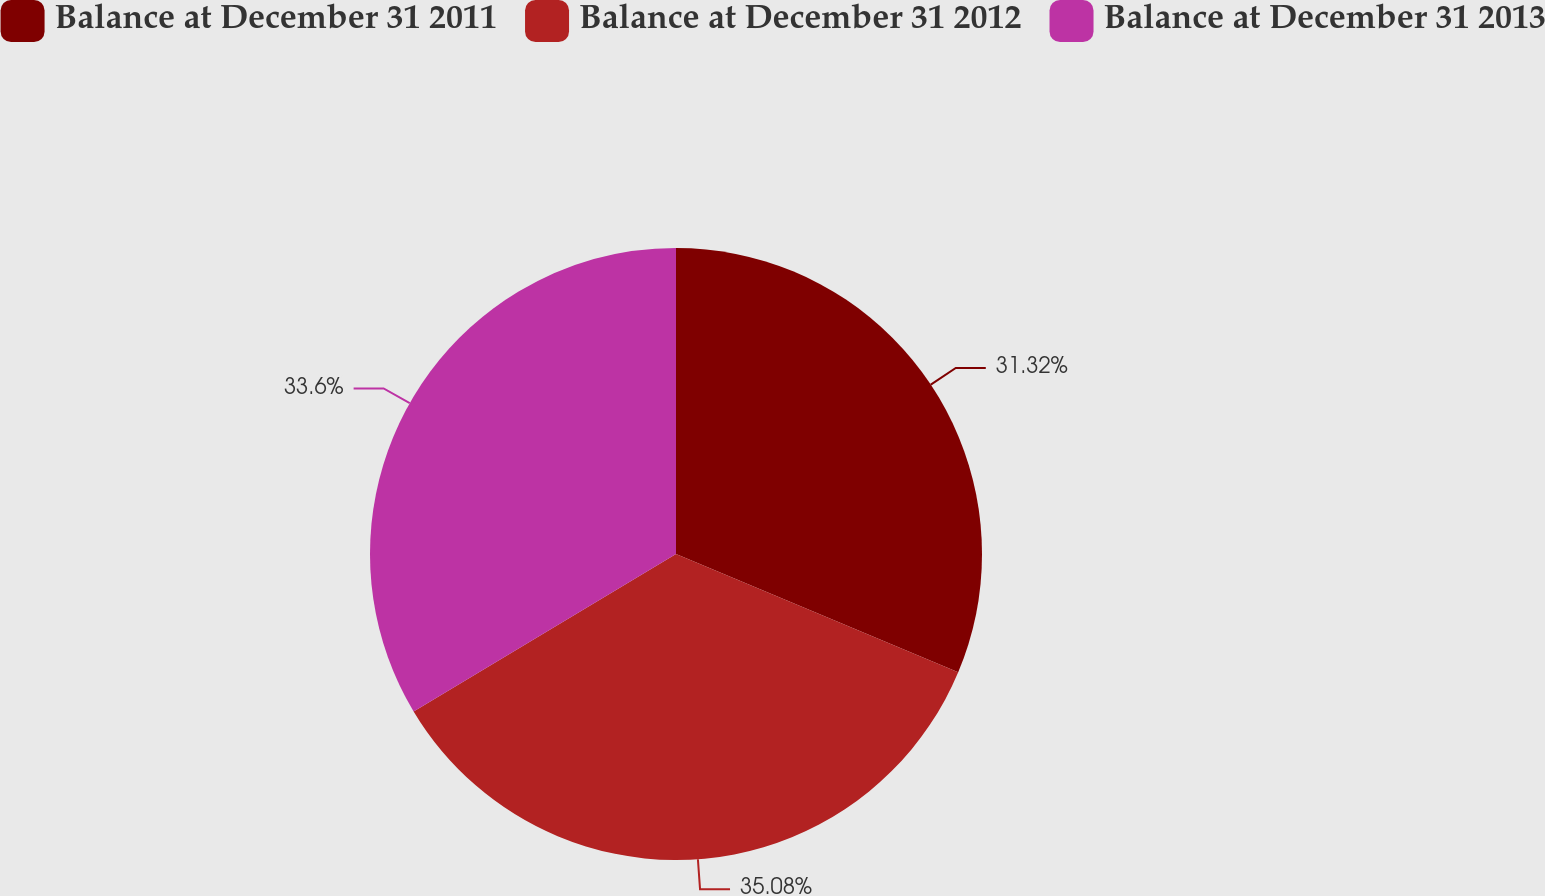Convert chart to OTSL. <chart><loc_0><loc_0><loc_500><loc_500><pie_chart><fcel>Balance at December 31 2011<fcel>Balance at December 31 2012<fcel>Balance at December 31 2013<nl><fcel>31.32%<fcel>35.08%<fcel>33.6%<nl></chart> 